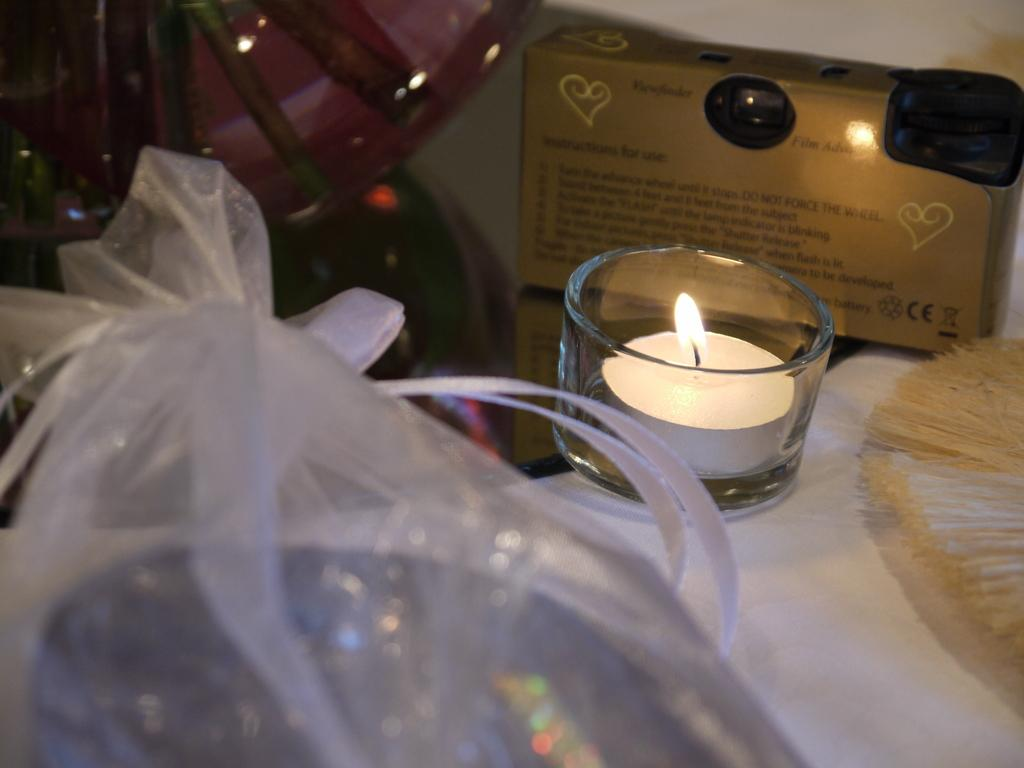What is the main object in the image? There is a candle with a flame in the image. How is the candle contained? The candle is in a glass container. Is the glass container covered? Yes, there is a cover on the glass container. What other object can be seen in the image? A brush is present on a platform in the image. What type of storage containers are visible in the image? There are carton boxes in the image. Can you describe any other objects in the image? There are other objects visible in the image, but their specific details are not mentioned in the provided facts. What type of drum is being played in the image? There is no drum present in the image; it features a candle with a flame in a glass container. What territory is being claimed by the objects in the image? The image does not depict any territorial claims; it simply shows a candle, a brush, carton boxes, and other unspecified objects. 